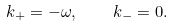<formula> <loc_0><loc_0><loc_500><loc_500>k _ { + } = - \omega , \quad k _ { - } = 0 .</formula> 